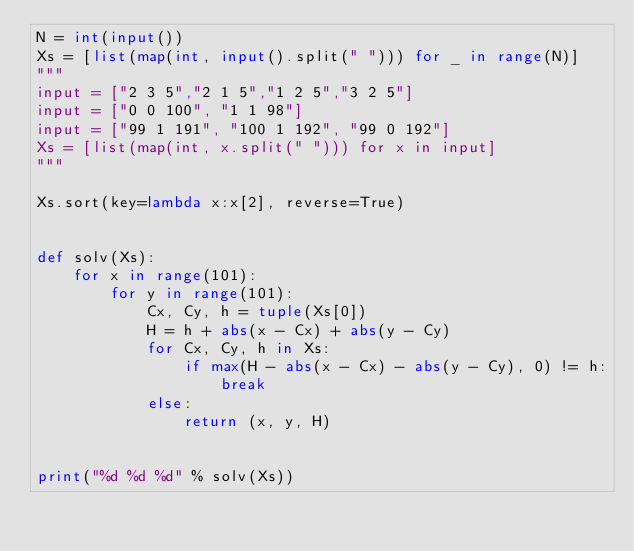Convert code to text. <code><loc_0><loc_0><loc_500><loc_500><_Python_>N = int(input())
Xs = [list(map(int, input().split(" "))) for _ in range(N)]
"""
input = ["2 3 5","2 1 5","1 2 5","3 2 5"]
input = ["0 0 100", "1 1 98"]
input = ["99 1 191", "100 1 192", "99 0 192"]
Xs = [list(map(int, x.split(" "))) for x in input]
"""

Xs.sort(key=lambda x:x[2], reverse=True)


def solv(Xs):
    for x in range(101):
        for y in range(101):
            Cx, Cy, h = tuple(Xs[0])
            H = h + abs(x - Cx) + abs(y - Cy)
            for Cx, Cy, h in Xs:
                if max(H - abs(x - Cx) - abs(y - Cy), 0) != h:
                    break
            else:
                return (x, y, H)


print("%d %d %d" % solv(Xs))
</code> 